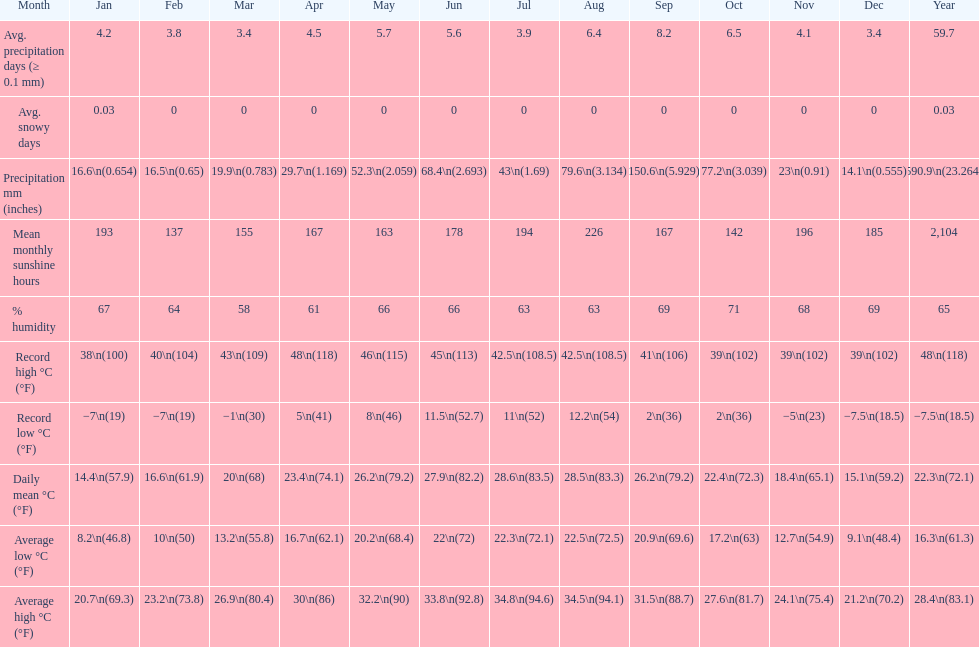Which month had the most sunny days? August. 